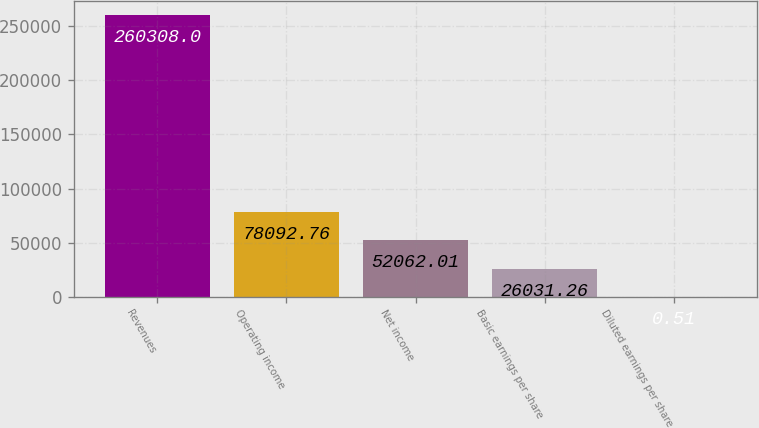Convert chart to OTSL. <chart><loc_0><loc_0><loc_500><loc_500><bar_chart><fcel>Revenues<fcel>Operating income<fcel>Net income<fcel>Basic earnings per share<fcel>Diluted earnings per share<nl><fcel>260308<fcel>78092.8<fcel>52062<fcel>26031.3<fcel>0.51<nl></chart> 